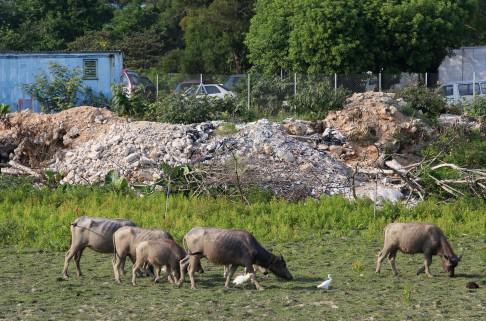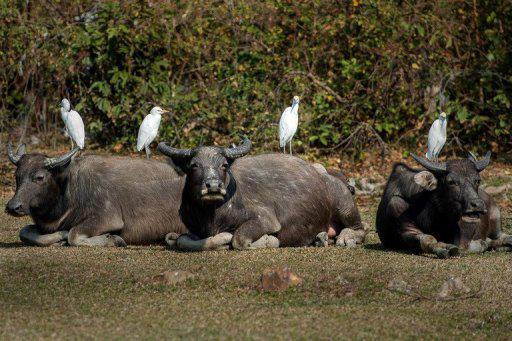The first image is the image on the left, the second image is the image on the right. Evaluate the accuracy of this statement regarding the images: "An image with reclining water buffalo includes at least one bird, which is not in flight.". Is it true? Answer yes or no. Yes. 